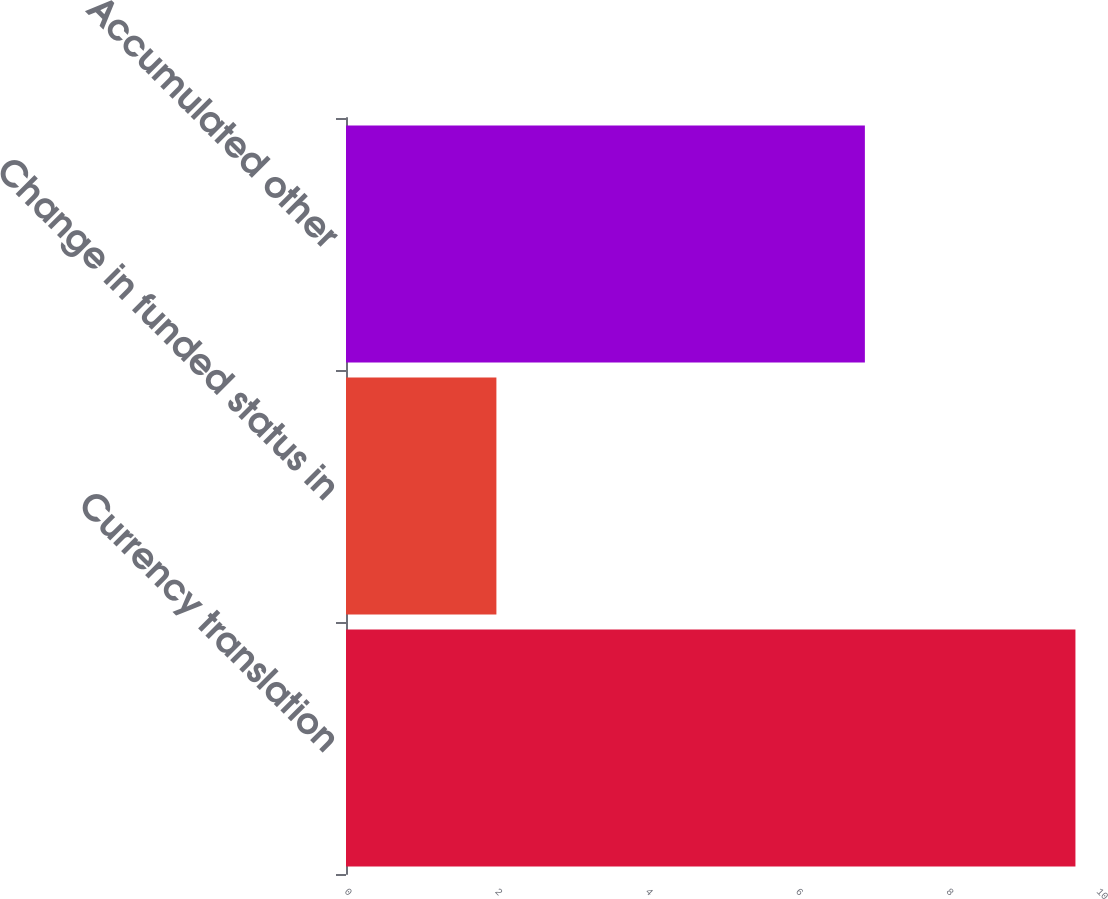Convert chart to OTSL. <chart><loc_0><loc_0><loc_500><loc_500><bar_chart><fcel>Currency translation<fcel>Change in funded status in<fcel>Accumulated other<nl><fcel>9.7<fcel>2<fcel>6.9<nl></chart> 